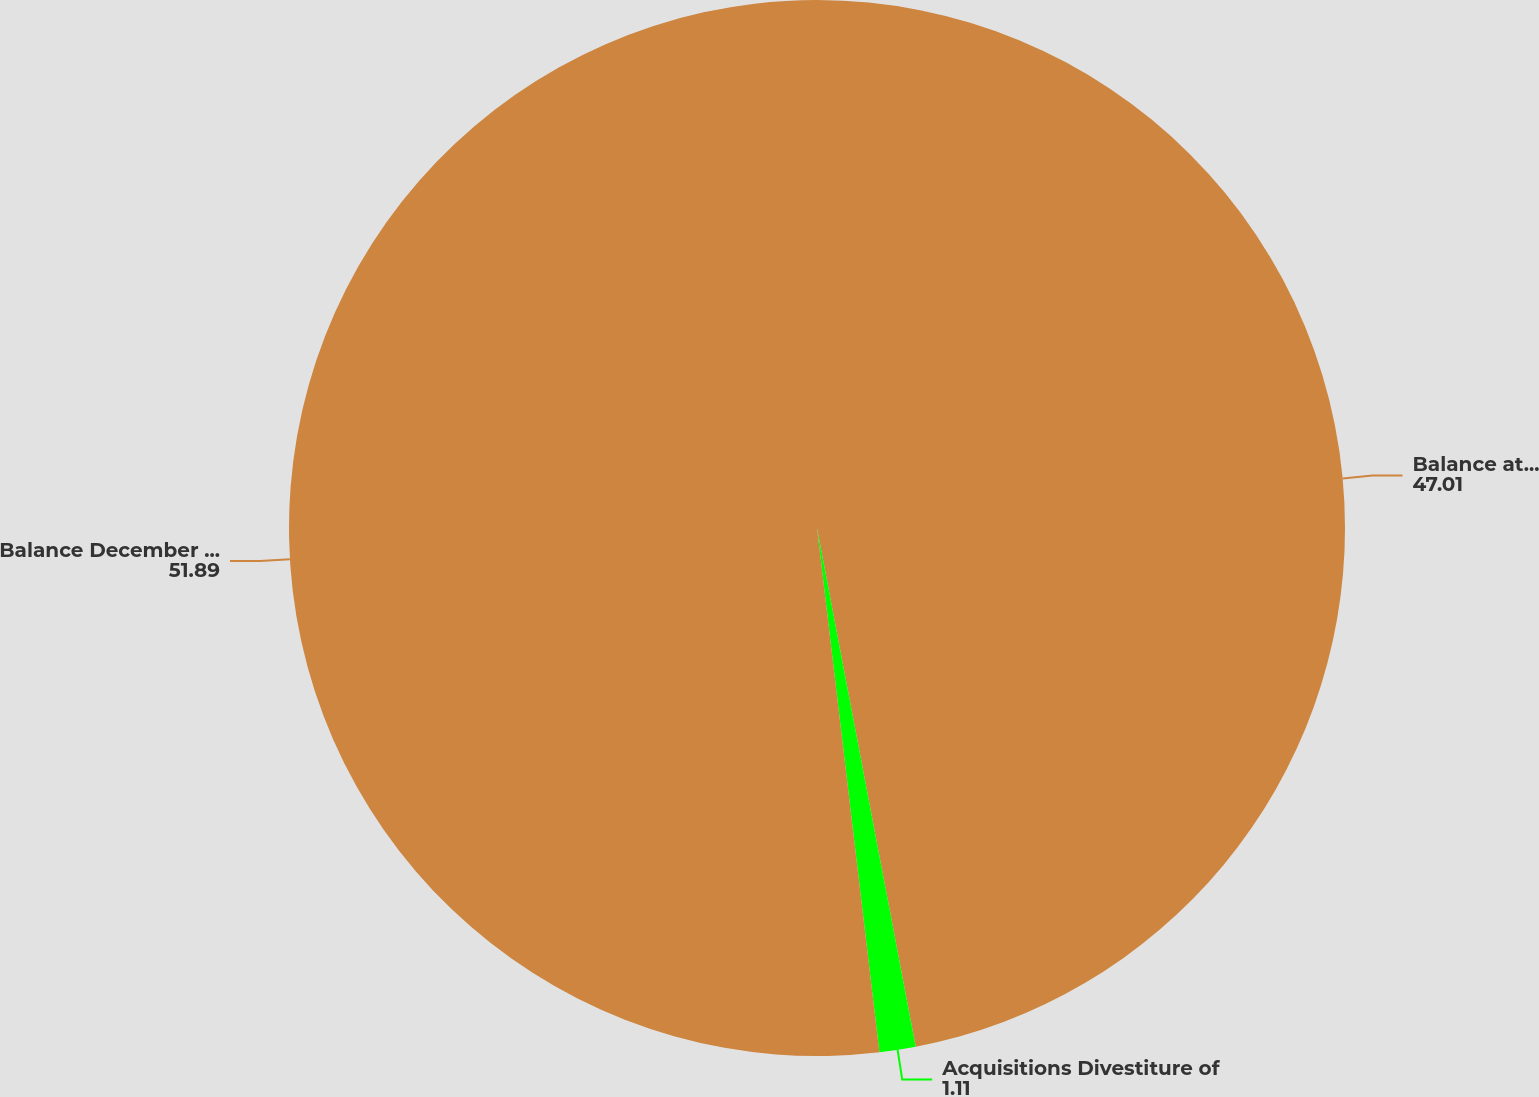Convert chart. <chart><loc_0><loc_0><loc_500><loc_500><pie_chart><fcel>Balance at January 1 2013<fcel>Acquisitions Divestiture of<fcel>Balance December 31 2014<nl><fcel>47.01%<fcel>1.11%<fcel>51.89%<nl></chart> 